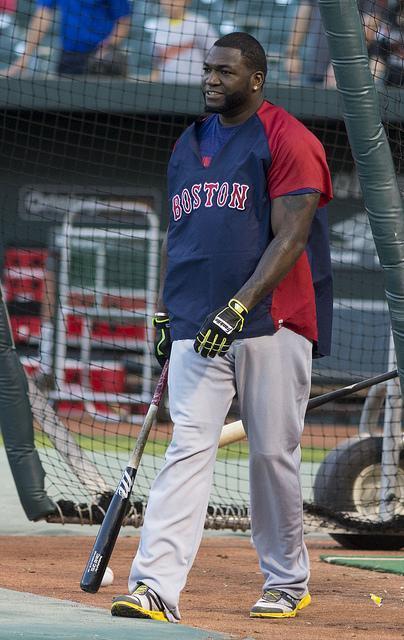How many people are there?
Give a very brief answer. 3. 